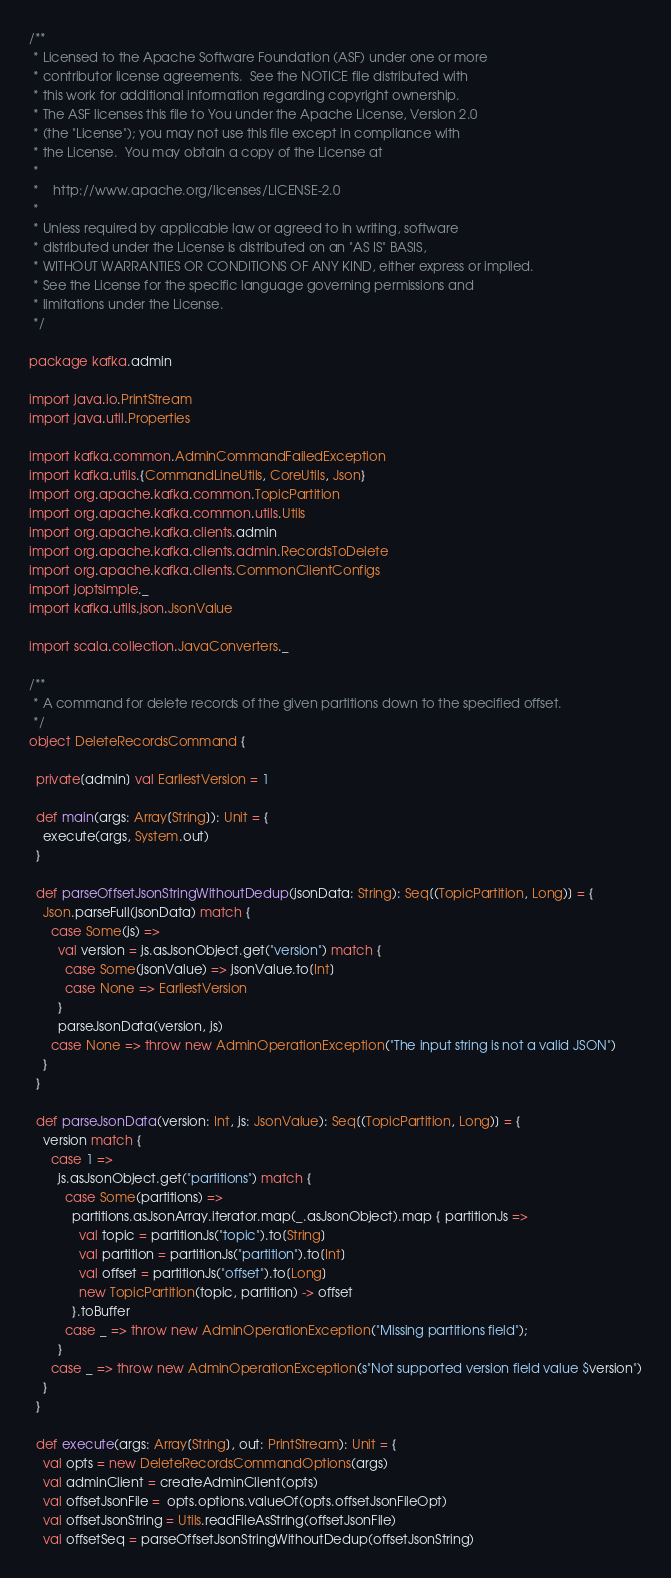<code> <loc_0><loc_0><loc_500><loc_500><_Scala_>/**
 * Licensed to the Apache Software Foundation (ASF) under one or more
 * contributor license agreements.  See the NOTICE file distributed with
 * this work for additional information regarding copyright ownership.
 * The ASF licenses this file to You under the Apache License, Version 2.0
 * (the "License"); you may not use this file except in compliance with
 * the License.  You may obtain a copy of the License at
 *
 *    http://www.apache.org/licenses/LICENSE-2.0
 *
 * Unless required by applicable law or agreed to in writing, software
 * distributed under the License is distributed on an "AS IS" BASIS,
 * WITHOUT WARRANTIES OR CONDITIONS OF ANY KIND, either express or implied.
 * See the License for the specific language governing permissions and
 * limitations under the License.
 */

package kafka.admin

import java.io.PrintStream
import java.util.Properties

import kafka.common.AdminCommandFailedException
import kafka.utils.{CommandLineUtils, CoreUtils, Json}
import org.apache.kafka.common.TopicPartition
import org.apache.kafka.common.utils.Utils
import org.apache.kafka.clients.admin
import org.apache.kafka.clients.admin.RecordsToDelete
import org.apache.kafka.clients.CommonClientConfigs
import joptsimple._
import kafka.utils.json.JsonValue

import scala.collection.JavaConverters._

/**
 * A command for delete records of the given partitions down to the specified offset.
 */
object DeleteRecordsCommand {

  private[admin] val EarliestVersion = 1

  def main(args: Array[String]): Unit = {
    execute(args, System.out)
  }

  def parseOffsetJsonStringWithoutDedup(jsonData: String): Seq[(TopicPartition, Long)] = {
    Json.parseFull(jsonData) match {
      case Some(js) =>
        val version = js.asJsonObject.get("version") match {
          case Some(jsonValue) => jsonValue.to[Int]
          case None => EarliestVersion
        }
        parseJsonData(version, js)
      case None => throw new AdminOperationException("The input string is not a valid JSON")
    }
  }

  def parseJsonData(version: Int, js: JsonValue): Seq[(TopicPartition, Long)] = {
    version match {
      case 1 =>
        js.asJsonObject.get("partitions") match {
          case Some(partitions) =>
            partitions.asJsonArray.iterator.map(_.asJsonObject).map { partitionJs =>
              val topic = partitionJs("topic").to[String]
              val partition = partitionJs("partition").to[Int]
              val offset = partitionJs("offset").to[Long]
              new TopicPartition(topic, partition) -> offset
            }.toBuffer
          case _ => throw new AdminOperationException("Missing partitions field");
        }
      case _ => throw new AdminOperationException(s"Not supported version field value $version")
    }
  }

  def execute(args: Array[String], out: PrintStream): Unit = {
    val opts = new DeleteRecordsCommandOptions(args)
    val adminClient = createAdminClient(opts)
    val offsetJsonFile =  opts.options.valueOf(opts.offsetJsonFileOpt)
    val offsetJsonString = Utils.readFileAsString(offsetJsonFile)
    val offsetSeq = parseOffsetJsonStringWithoutDedup(offsetJsonString)
</code> 